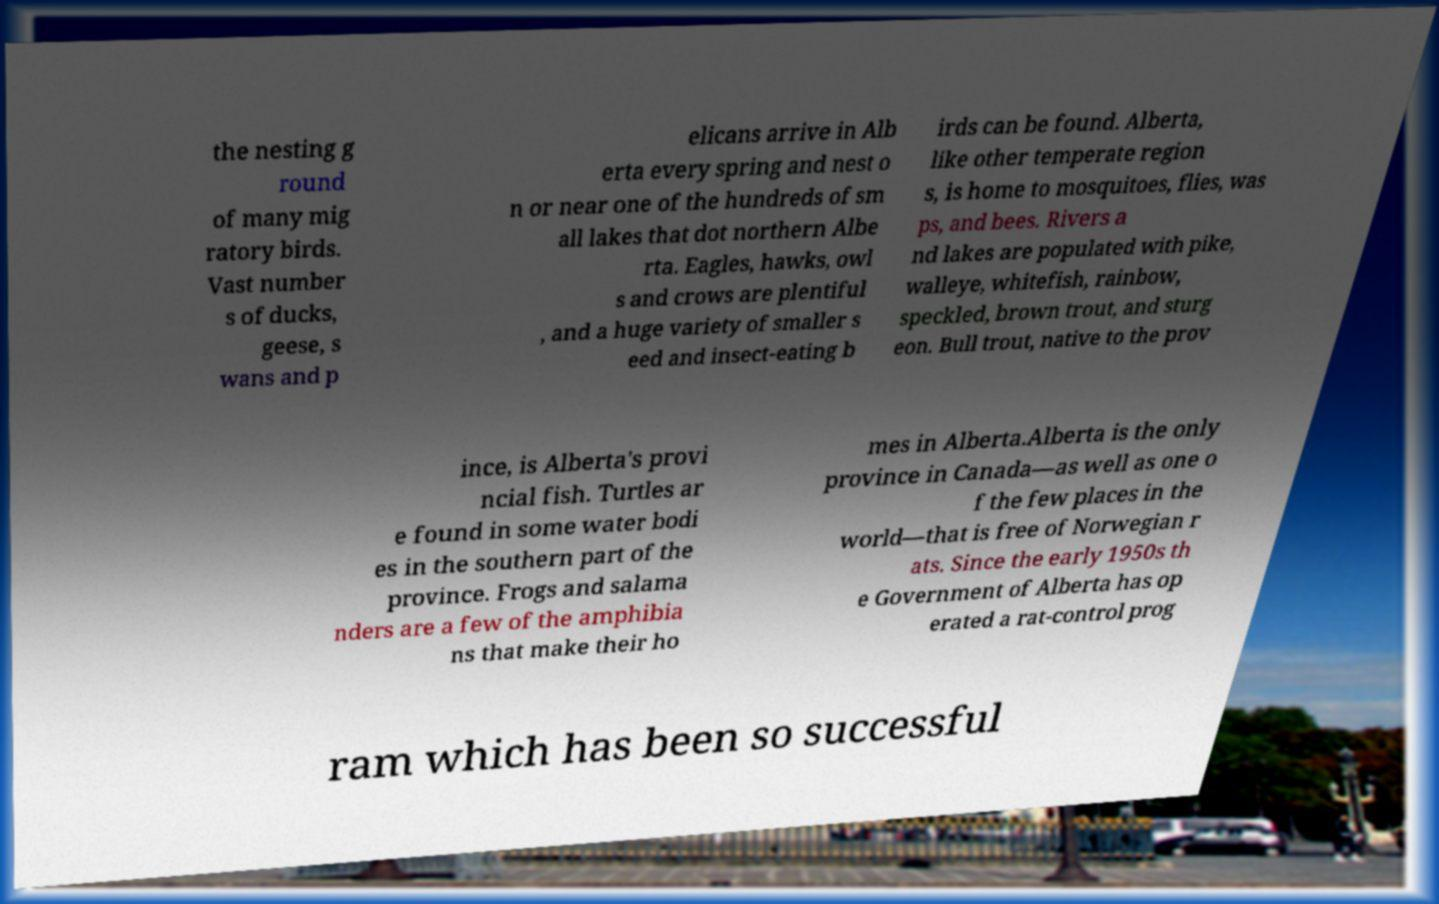What messages or text are displayed in this image? I need them in a readable, typed format. the nesting g round of many mig ratory birds. Vast number s of ducks, geese, s wans and p elicans arrive in Alb erta every spring and nest o n or near one of the hundreds of sm all lakes that dot northern Albe rta. Eagles, hawks, owl s and crows are plentiful , and a huge variety of smaller s eed and insect-eating b irds can be found. Alberta, like other temperate region s, is home to mosquitoes, flies, was ps, and bees. Rivers a nd lakes are populated with pike, walleye, whitefish, rainbow, speckled, brown trout, and sturg eon. Bull trout, native to the prov ince, is Alberta's provi ncial fish. Turtles ar e found in some water bodi es in the southern part of the province. Frogs and salama nders are a few of the amphibia ns that make their ho mes in Alberta.Alberta is the only province in Canada—as well as one o f the few places in the world—that is free of Norwegian r ats. Since the early 1950s th e Government of Alberta has op erated a rat-control prog ram which has been so successful 